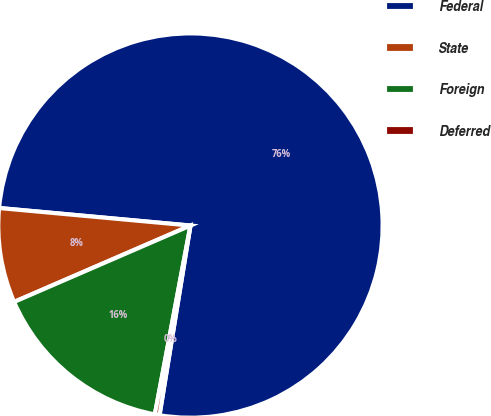Convert chart. <chart><loc_0><loc_0><loc_500><loc_500><pie_chart><fcel>Federal<fcel>State<fcel>Foreign<fcel>Deferred<nl><fcel>76.12%<fcel>7.96%<fcel>15.53%<fcel>0.39%<nl></chart> 